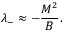<formula> <loc_0><loc_0><loc_500><loc_500>\lambda _ { - } \approx - { \frac { M ^ { 2 } } { B } } .</formula> 